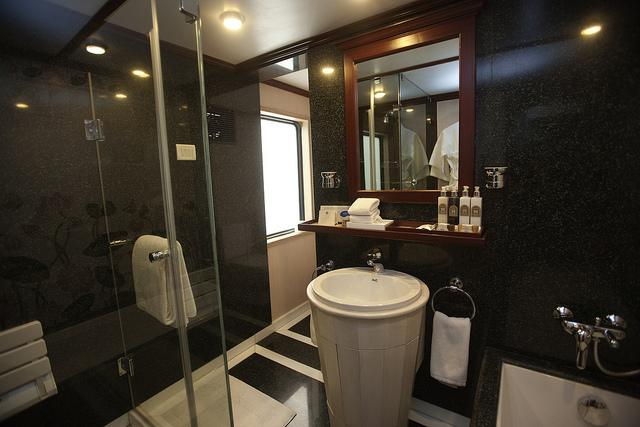What is most likely outside the doorway?

Choices:
A) bedroom
B) living room
C) kitchen
D) garage bedroom 